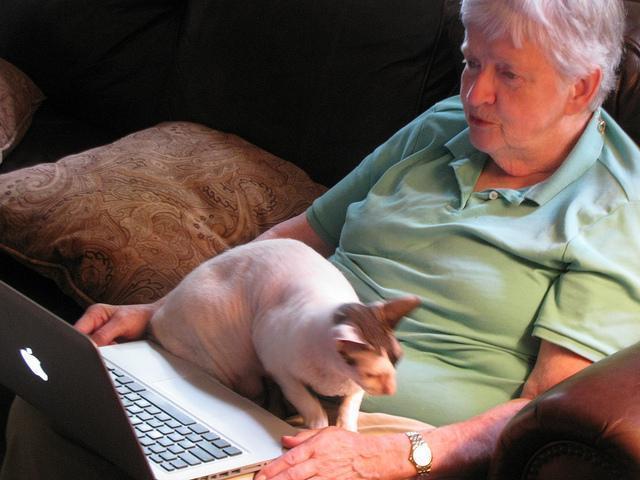How many couches are there?
Give a very brief answer. 2. 